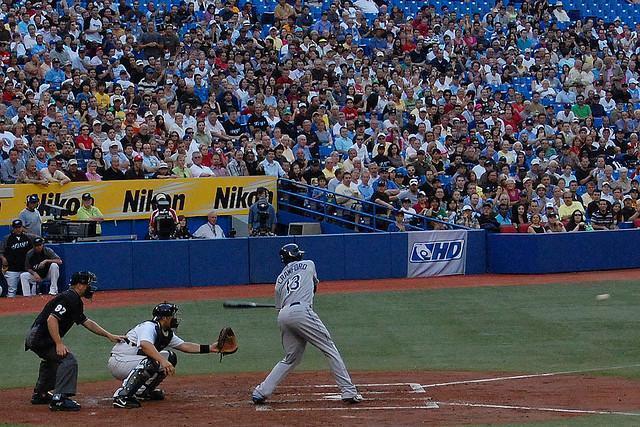The player swinging has the same dominant hand as what person?
Select the accurate answer and provide justification: `Answer: choice
Rationale: srationale.`
Options: Kris bryant, mike trout, fred mcgriff, manny ramirez. Answer: fred mcgriff.
Rationale: They are using the same hand. 